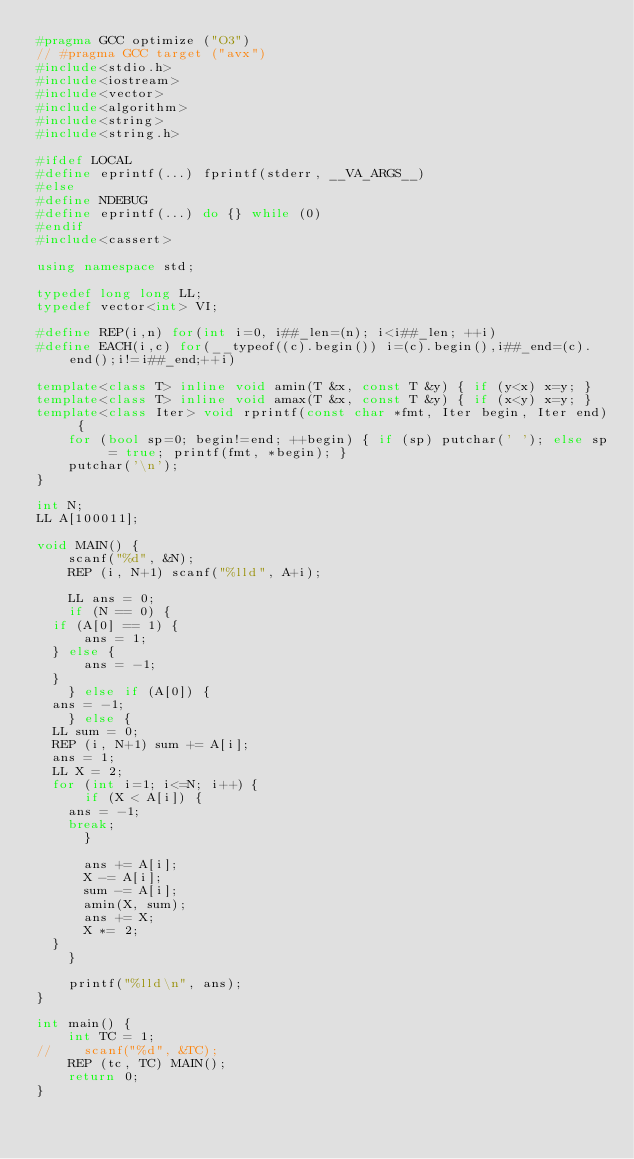<code> <loc_0><loc_0><loc_500><loc_500><_C++_>#pragma GCC optimize ("O3")
// #pragma GCC target ("avx")
#include<stdio.h>
#include<iostream>
#include<vector>
#include<algorithm>
#include<string>
#include<string.h>

#ifdef LOCAL
#define eprintf(...) fprintf(stderr, __VA_ARGS__)
#else
#define NDEBUG
#define eprintf(...) do {} while (0)
#endif
#include<cassert>

using namespace std;

typedef long long LL;
typedef vector<int> VI;

#define REP(i,n) for(int i=0, i##_len=(n); i<i##_len; ++i)
#define EACH(i,c) for(__typeof((c).begin()) i=(c).begin(),i##_end=(c).end();i!=i##_end;++i)

template<class T> inline void amin(T &x, const T &y) { if (y<x) x=y; }
template<class T> inline void amax(T &x, const T &y) { if (x<y) x=y; }
template<class Iter> void rprintf(const char *fmt, Iter begin, Iter end) {
    for (bool sp=0; begin!=end; ++begin) { if (sp) putchar(' '); else sp = true; printf(fmt, *begin); }
    putchar('\n');
}

int N;
LL A[100011];

void MAIN() {
    scanf("%d", &N);
    REP (i, N+1) scanf("%lld", A+i);

    LL ans = 0;
    if (N == 0) {
	if (A[0] == 1) {
	    ans = 1;
	} else {
	    ans = -1;
	}
    } else if (A[0]) {
	ans = -1;
    } else {
	LL sum = 0;
	REP (i, N+1) sum += A[i];
	ans = 1;
	LL X = 2;
	for (int i=1; i<=N; i++) {
	    if (X < A[i]) {
		ans = -1;
		break;
	    }

	    ans += A[i];
	    X -= A[i];
	    sum -= A[i];
	    amin(X, sum);
	    ans += X;
	    X *= 2;
	}
    }

    printf("%lld\n", ans);
}

int main() {
    int TC = 1;
//    scanf("%d", &TC);
    REP (tc, TC) MAIN();
    return 0;
}

</code> 